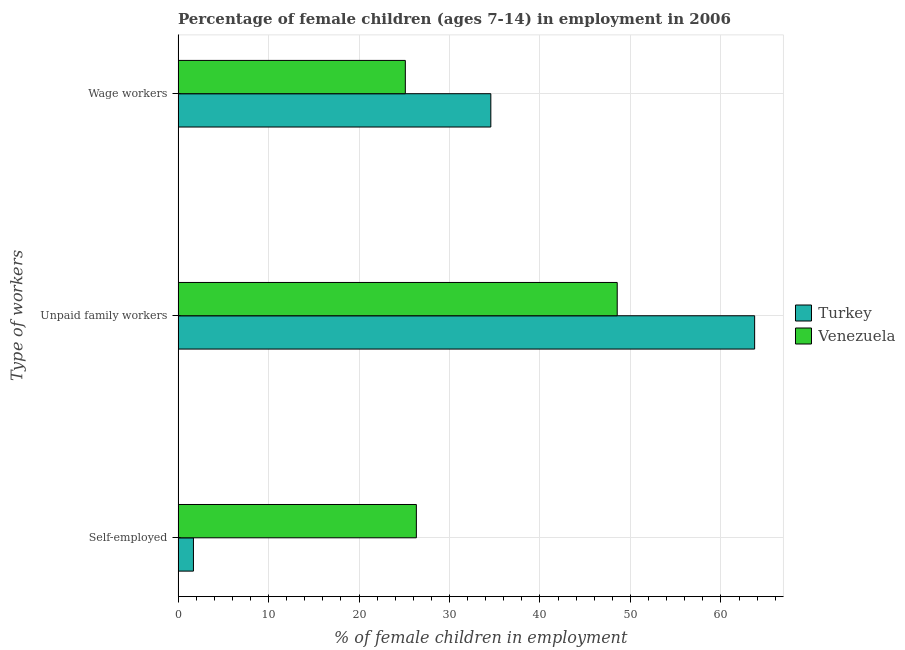How many different coloured bars are there?
Offer a terse response. 2. How many groups of bars are there?
Give a very brief answer. 3. Are the number of bars per tick equal to the number of legend labels?
Keep it short and to the point. Yes. Are the number of bars on each tick of the Y-axis equal?
Your answer should be very brief. Yes. What is the label of the 1st group of bars from the top?
Offer a very short reply. Wage workers. Across all countries, what is the maximum percentage of children employed as unpaid family workers?
Ensure brevity in your answer.  63.73. In which country was the percentage of self employed children maximum?
Your response must be concise. Venezuela. What is the total percentage of children employed as unpaid family workers in the graph?
Give a very brief answer. 112.27. What is the difference between the percentage of children employed as unpaid family workers in Venezuela and that in Turkey?
Give a very brief answer. -15.19. What is the difference between the percentage of children employed as unpaid family workers in Turkey and the percentage of children employed as wage workers in Venezuela?
Provide a short and direct response. 38.61. What is the average percentage of children employed as unpaid family workers per country?
Offer a terse response. 56.13. What is the difference between the percentage of self employed children and percentage of children employed as unpaid family workers in Venezuela?
Your answer should be very brief. -22.2. In how many countries, is the percentage of self employed children greater than 40 %?
Keep it short and to the point. 0. What is the ratio of the percentage of children employed as wage workers in Venezuela to that in Turkey?
Offer a very short reply. 0.73. Is the percentage of self employed children in Turkey less than that in Venezuela?
Provide a short and direct response. Yes. Is the difference between the percentage of children employed as unpaid family workers in Venezuela and Turkey greater than the difference between the percentage of self employed children in Venezuela and Turkey?
Give a very brief answer. No. What is the difference between the highest and the second highest percentage of children employed as wage workers?
Provide a succinct answer. 9.45. What is the difference between the highest and the lowest percentage of self employed children?
Your answer should be compact. 24.64. Is the sum of the percentage of self employed children in Turkey and Venezuela greater than the maximum percentage of children employed as wage workers across all countries?
Give a very brief answer. No. What does the 1st bar from the top in Wage workers represents?
Offer a terse response. Venezuela. What does the 2nd bar from the bottom in Unpaid family workers represents?
Provide a succinct answer. Venezuela. Are all the bars in the graph horizontal?
Your answer should be very brief. Yes. Does the graph contain grids?
Provide a short and direct response. Yes. How are the legend labels stacked?
Offer a terse response. Vertical. What is the title of the graph?
Give a very brief answer. Percentage of female children (ages 7-14) in employment in 2006. What is the label or title of the X-axis?
Your answer should be very brief. % of female children in employment. What is the label or title of the Y-axis?
Ensure brevity in your answer.  Type of workers. What is the % of female children in employment in Turkey in Self-employed?
Keep it short and to the point. 1.7. What is the % of female children in employment in Venezuela in Self-employed?
Offer a terse response. 26.34. What is the % of female children in employment of Turkey in Unpaid family workers?
Provide a succinct answer. 63.73. What is the % of female children in employment in Venezuela in Unpaid family workers?
Your answer should be very brief. 48.54. What is the % of female children in employment in Turkey in Wage workers?
Offer a very short reply. 34.57. What is the % of female children in employment in Venezuela in Wage workers?
Your answer should be compact. 25.12. Across all Type of workers, what is the maximum % of female children in employment of Turkey?
Make the answer very short. 63.73. Across all Type of workers, what is the maximum % of female children in employment in Venezuela?
Your answer should be compact. 48.54. Across all Type of workers, what is the minimum % of female children in employment of Turkey?
Your answer should be compact. 1.7. Across all Type of workers, what is the minimum % of female children in employment of Venezuela?
Keep it short and to the point. 25.12. What is the total % of female children in employment of Venezuela in the graph?
Keep it short and to the point. 100. What is the difference between the % of female children in employment of Turkey in Self-employed and that in Unpaid family workers?
Give a very brief answer. -62.03. What is the difference between the % of female children in employment of Venezuela in Self-employed and that in Unpaid family workers?
Make the answer very short. -22.2. What is the difference between the % of female children in employment in Turkey in Self-employed and that in Wage workers?
Offer a terse response. -32.87. What is the difference between the % of female children in employment of Venezuela in Self-employed and that in Wage workers?
Offer a terse response. 1.22. What is the difference between the % of female children in employment in Turkey in Unpaid family workers and that in Wage workers?
Make the answer very short. 29.16. What is the difference between the % of female children in employment in Venezuela in Unpaid family workers and that in Wage workers?
Your response must be concise. 23.42. What is the difference between the % of female children in employment of Turkey in Self-employed and the % of female children in employment of Venezuela in Unpaid family workers?
Provide a succinct answer. -46.84. What is the difference between the % of female children in employment in Turkey in Self-employed and the % of female children in employment in Venezuela in Wage workers?
Keep it short and to the point. -23.42. What is the difference between the % of female children in employment in Turkey in Unpaid family workers and the % of female children in employment in Venezuela in Wage workers?
Make the answer very short. 38.61. What is the average % of female children in employment of Turkey per Type of workers?
Your answer should be compact. 33.33. What is the average % of female children in employment in Venezuela per Type of workers?
Ensure brevity in your answer.  33.33. What is the difference between the % of female children in employment of Turkey and % of female children in employment of Venezuela in Self-employed?
Offer a very short reply. -24.64. What is the difference between the % of female children in employment in Turkey and % of female children in employment in Venezuela in Unpaid family workers?
Your response must be concise. 15.19. What is the difference between the % of female children in employment of Turkey and % of female children in employment of Venezuela in Wage workers?
Give a very brief answer. 9.45. What is the ratio of the % of female children in employment of Turkey in Self-employed to that in Unpaid family workers?
Your response must be concise. 0.03. What is the ratio of the % of female children in employment of Venezuela in Self-employed to that in Unpaid family workers?
Provide a short and direct response. 0.54. What is the ratio of the % of female children in employment in Turkey in Self-employed to that in Wage workers?
Ensure brevity in your answer.  0.05. What is the ratio of the % of female children in employment of Venezuela in Self-employed to that in Wage workers?
Offer a very short reply. 1.05. What is the ratio of the % of female children in employment in Turkey in Unpaid family workers to that in Wage workers?
Make the answer very short. 1.84. What is the ratio of the % of female children in employment of Venezuela in Unpaid family workers to that in Wage workers?
Keep it short and to the point. 1.93. What is the difference between the highest and the second highest % of female children in employment of Turkey?
Your answer should be compact. 29.16. What is the difference between the highest and the lowest % of female children in employment in Turkey?
Your response must be concise. 62.03. What is the difference between the highest and the lowest % of female children in employment in Venezuela?
Offer a terse response. 23.42. 